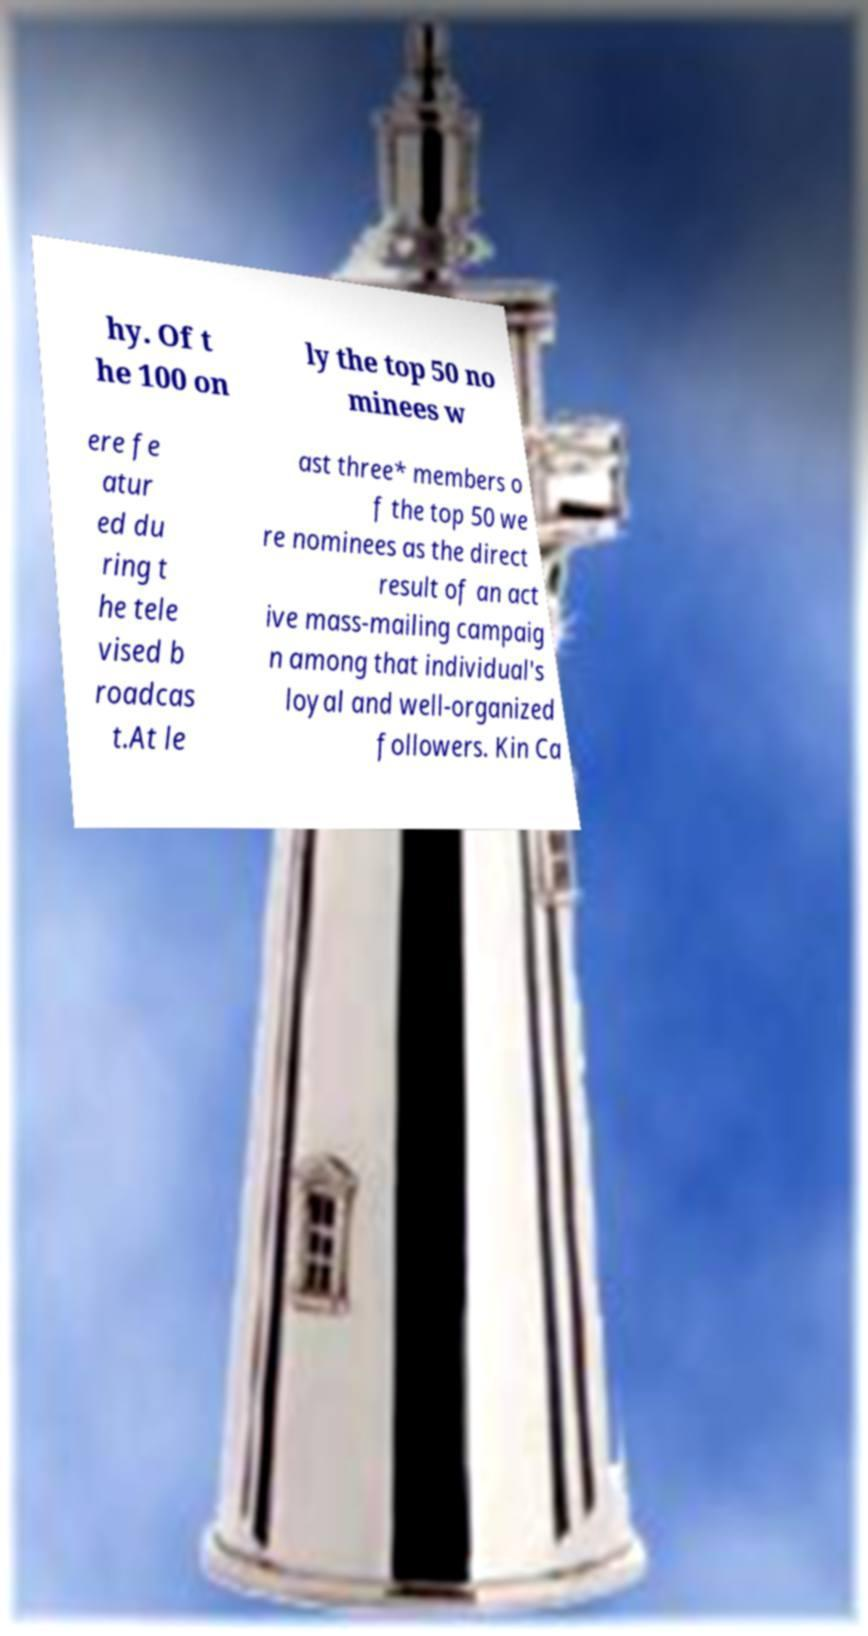Could you assist in decoding the text presented in this image and type it out clearly? hy. Of t he 100 on ly the top 50 no minees w ere fe atur ed du ring t he tele vised b roadcas t.At le ast three* members o f the top 50 we re nominees as the direct result of an act ive mass-mailing campaig n among that individual's loyal and well-organized followers. Kin Ca 